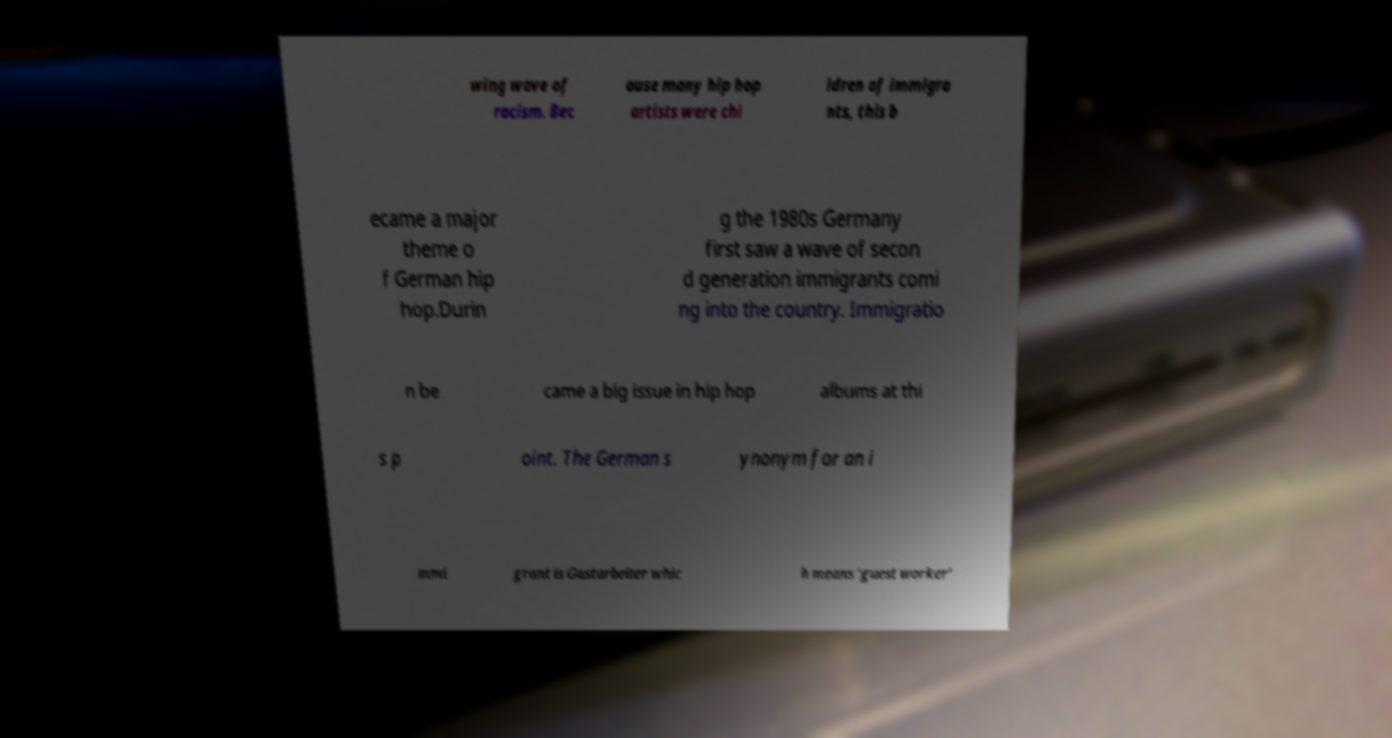Could you assist in decoding the text presented in this image and type it out clearly? wing wave of racism. Bec ause many hip hop artists were chi ldren of immigra nts, this b ecame a major theme o f German hip hop.Durin g the 1980s Germany first saw a wave of secon d generation immigrants comi ng into the country. Immigratio n be came a big issue in hip hop albums at thi s p oint. The German s ynonym for an i mmi grant is Gastarbeiter whic h means 'guest worker' 